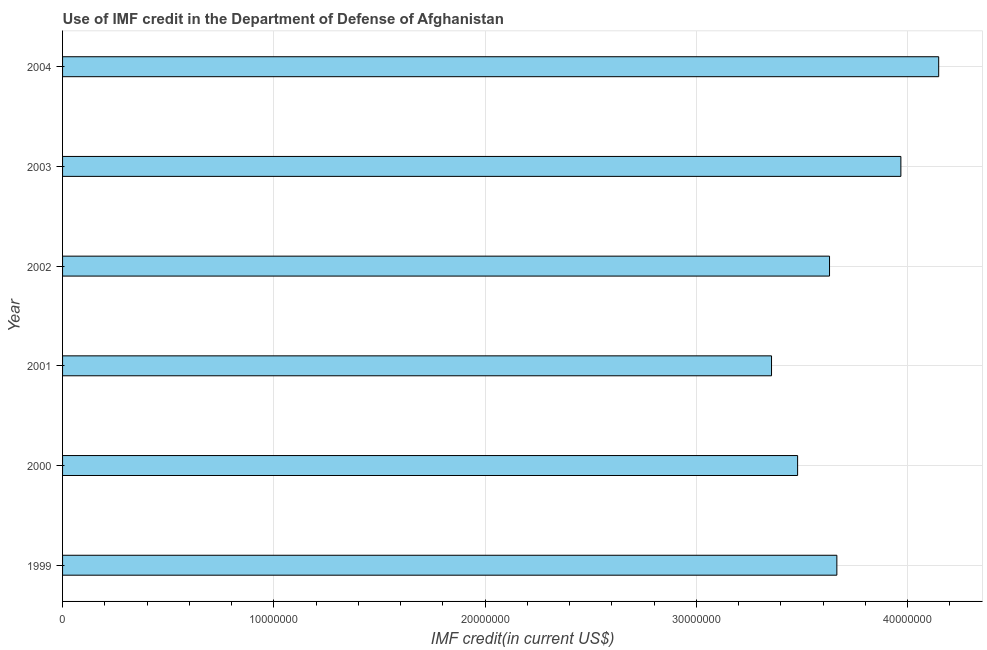What is the title of the graph?
Ensure brevity in your answer.  Use of IMF credit in the Department of Defense of Afghanistan. What is the label or title of the X-axis?
Ensure brevity in your answer.  IMF credit(in current US$). What is the use of imf credit in dod in 2003?
Keep it short and to the point. 3.97e+07. Across all years, what is the maximum use of imf credit in dod?
Provide a short and direct response. 4.15e+07. Across all years, what is the minimum use of imf credit in dod?
Your response must be concise. 3.36e+07. In which year was the use of imf credit in dod maximum?
Make the answer very short. 2004. What is the sum of the use of imf credit in dod?
Provide a succinct answer. 2.22e+08. What is the difference between the use of imf credit in dod in 2003 and 2004?
Keep it short and to the point. -1.79e+06. What is the average use of imf credit in dod per year?
Your answer should be very brief. 3.71e+07. What is the median use of imf credit in dod?
Provide a short and direct response. 3.65e+07. In how many years, is the use of imf credit in dod greater than 12000000 US$?
Give a very brief answer. 6. Do a majority of the years between 2000 and 2001 (inclusive) have use of imf credit in dod greater than 18000000 US$?
Your answer should be compact. Yes. What is the ratio of the use of imf credit in dod in 2002 to that in 2004?
Your response must be concise. 0.88. Is the use of imf credit in dod in 2000 less than that in 2001?
Make the answer very short. No. What is the difference between the highest and the second highest use of imf credit in dod?
Your answer should be very brief. 1.79e+06. Is the sum of the use of imf credit in dod in 2001 and 2004 greater than the maximum use of imf credit in dod across all years?
Provide a succinct answer. Yes. What is the difference between the highest and the lowest use of imf credit in dod?
Ensure brevity in your answer.  7.91e+06. How many bars are there?
Ensure brevity in your answer.  6. Are all the bars in the graph horizontal?
Ensure brevity in your answer.  Yes. What is the difference between two consecutive major ticks on the X-axis?
Give a very brief answer. 1.00e+07. What is the IMF credit(in current US$) in 1999?
Ensure brevity in your answer.  3.66e+07. What is the IMF credit(in current US$) of 2000?
Give a very brief answer. 3.48e+07. What is the IMF credit(in current US$) in 2001?
Offer a terse response. 3.36e+07. What is the IMF credit(in current US$) of 2002?
Make the answer very short. 3.63e+07. What is the IMF credit(in current US$) of 2003?
Provide a short and direct response. 3.97e+07. What is the IMF credit(in current US$) of 2004?
Offer a terse response. 4.15e+07. What is the difference between the IMF credit(in current US$) in 1999 and 2000?
Ensure brevity in your answer.  1.86e+06. What is the difference between the IMF credit(in current US$) in 1999 and 2001?
Your answer should be compact. 3.09e+06. What is the difference between the IMF credit(in current US$) in 1999 and 2002?
Offer a very short reply. 3.47e+05. What is the difference between the IMF credit(in current US$) in 1999 and 2003?
Your response must be concise. -3.03e+06. What is the difference between the IMF credit(in current US$) in 1999 and 2004?
Keep it short and to the point. -4.82e+06. What is the difference between the IMF credit(in current US$) in 2000 and 2001?
Give a very brief answer. 1.23e+06. What is the difference between the IMF credit(in current US$) in 2000 and 2002?
Give a very brief answer. -1.51e+06. What is the difference between the IMF credit(in current US$) in 2000 and 2003?
Your response must be concise. -4.89e+06. What is the difference between the IMF credit(in current US$) in 2000 and 2004?
Make the answer very short. -6.68e+06. What is the difference between the IMF credit(in current US$) in 2001 and 2002?
Make the answer very short. -2.74e+06. What is the difference between the IMF credit(in current US$) in 2001 and 2003?
Your response must be concise. -6.12e+06. What is the difference between the IMF credit(in current US$) in 2001 and 2004?
Give a very brief answer. -7.91e+06. What is the difference between the IMF credit(in current US$) in 2002 and 2003?
Ensure brevity in your answer.  -3.38e+06. What is the difference between the IMF credit(in current US$) in 2002 and 2004?
Your response must be concise. -5.17e+06. What is the difference between the IMF credit(in current US$) in 2003 and 2004?
Offer a terse response. -1.79e+06. What is the ratio of the IMF credit(in current US$) in 1999 to that in 2000?
Your answer should be very brief. 1.05. What is the ratio of the IMF credit(in current US$) in 1999 to that in 2001?
Offer a very short reply. 1.09. What is the ratio of the IMF credit(in current US$) in 1999 to that in 2003?
Your answer should be very brief. 0.92. What is the ratio of the IMF credit(in current US$) in 1999 to that in 2004?
Make the answer very short. 0.88. What is the ratio of the IMF credit(in current US$) in 2000 to that in 2001?
Give a very brief answer. 1.04. What is the ratio of the IMF credit(in current US$) in 2000 to that in 2002?
Provide a succinct answer. 0.96. What is the ratio of the IMF credit(in current US$) in 2000 to that in 2003?
Provide a short and direct response. 0.88. What is the ratio of the IMF credit(in current US$) in 2000 to that in 2004?
Offer a very short reply. 0.84. What is the ratio of the IMF credit(in current US$) in 2001 to that in 2002?
Provide a short and direct response. 0.92. What is the ratio of the IMF credit(in current US$) in 2001 to that in 2003?
Ensure brevity in your answer.  0.85. What is the ratio of the IMF credit(in current US$) in 2001 to that in 2004?
Provide a short and direct response. 0.81. What is the ratio of the IMF credit(in current US$) in 2002 to that in 2003?
Your answer should be very brief. 0.92. What is the ratio of the IMF credit(in current US$) in 2002 to that in 2004?
Your answer should be compact. 0.88. What is the ratio of the IMF credit(in current US$) in 2003 to that in 2004?
Your response must be concise. 0.96. 